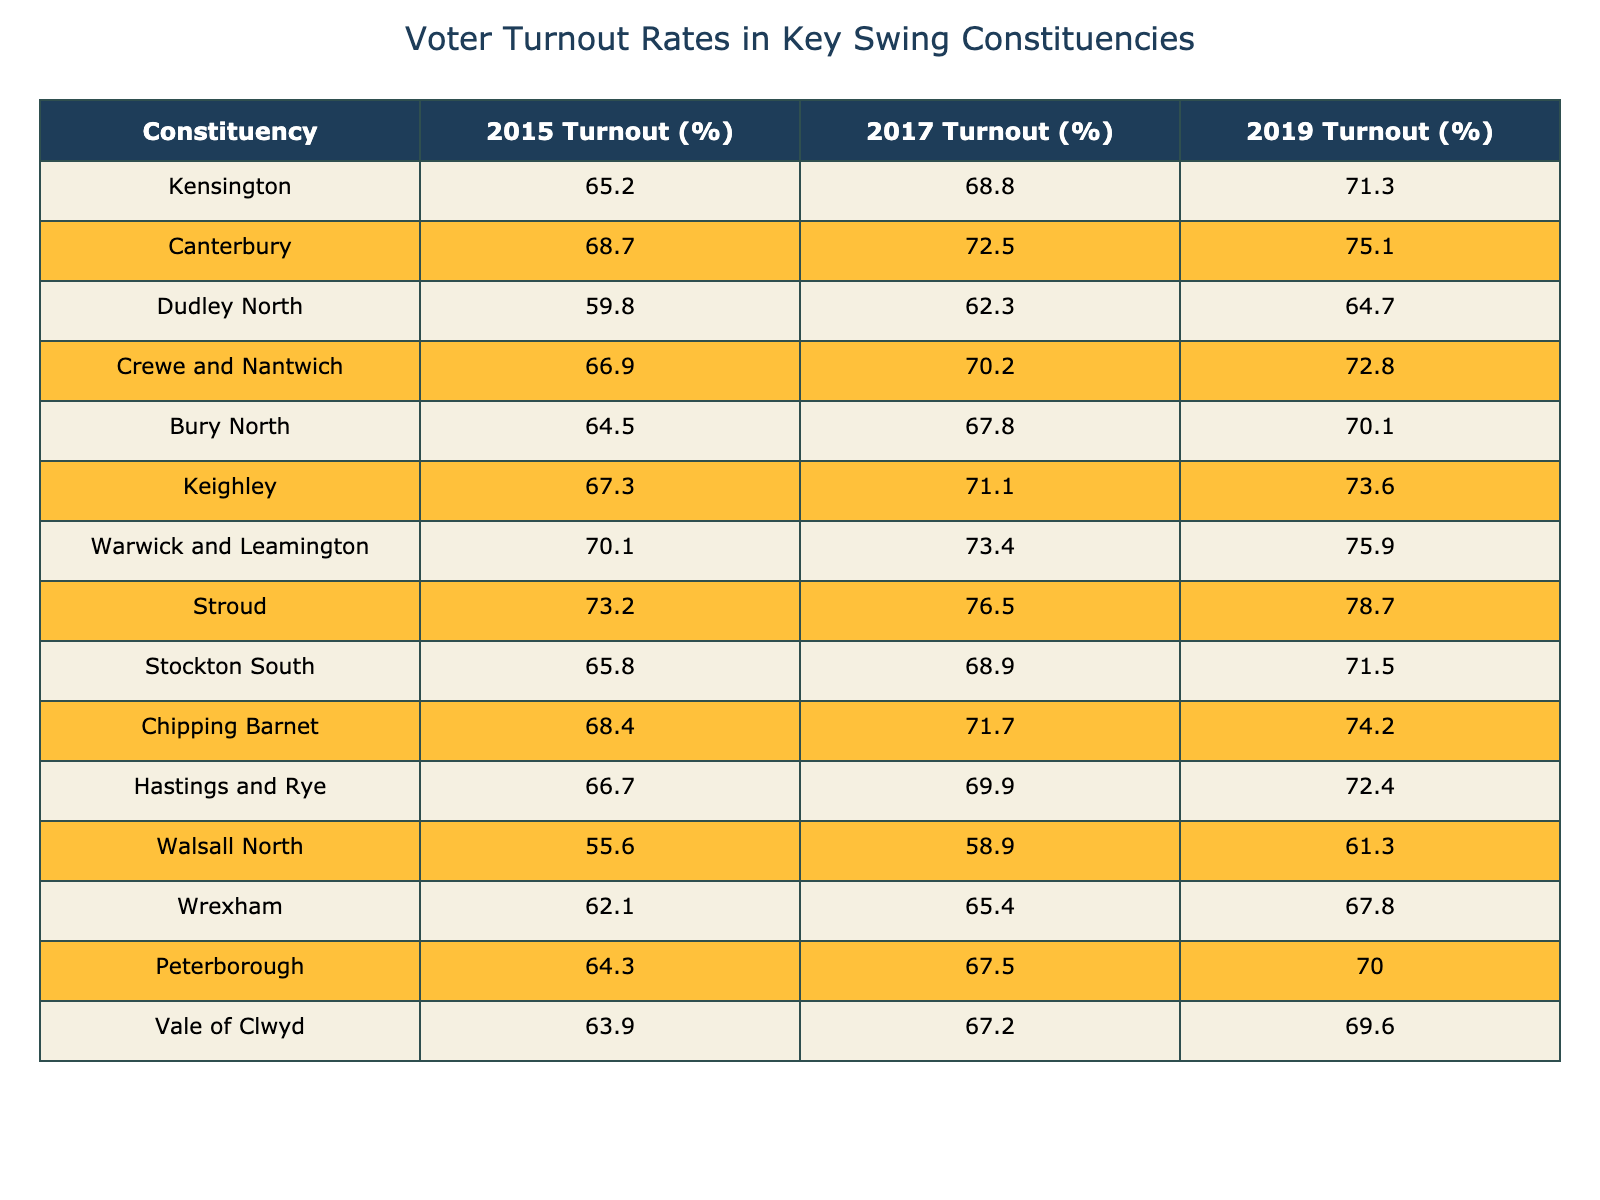What was the voter turnout rate in Kensington in 2017? The voter turnout rate in Kensington for 2017 is listed in the table as 68.8%. Therefore, the answer is straightforward as it can be directly retrieved from the table.
Answer: 68.8% Which constituency had the highest turnout in 2019? In 2019, the turnout percentages of constituencies are compared. By looking through the list, Stroud has the highest turnout rate at 78.7%.
Answer: Stroud What is the average voter turnout rate in the 2015 elections for constituencies starting with the letter 'C'? To find this, we first identify the constituencies that start with 'C': Canterbury (68.7%) and Crewe and Nantwich (66.9%). We then calculate the average: (68.7 + 66.9) / 2 = 67.8%.
Answer: 67.8% Did Walsall North have a higher voter turnout in 2019 than in 2015? In the table, Walsall North's turnout was 55.6% in 2015 and rose to 61.3% in 2019. Therefore, to answer the question, we compare the two values: 61.3% is higher than 55.6%.
Answer: Yes What was the difference in voter turnout for Peterborough between 2017 and 2019? We check the turnout rates for Peterborough: it was 67.5% in 2017 and 70.0% in 2019. To find the difference, we calculate 70.0% - 67.5% = 2.5%.
Answer: 2.5% In how many constituencies did the voter turnout increase from 2015 to 2019? We analyze the table to count the constituencies with increased turnout: Kensington, Canterbury, Dudley North, Crewe and Nantwich, Bury North, Keighley, Warwick and Leamington, Stroud, Stockton South, Chipping Barnet, Hastings and Rye, Wrexham, and Vale of Clwyd all showed an increase. Walsall North is the only constituency that did not. This makes a total of 13 constituencies.
Answer: 13 What was the percentage increase in turnout for Hastings and Rye from 2015 to 2019? We observe Hastings and Rye's turnout rates: it was 66.7% in 2015 and 72.4% in 2019. The percentage increase is calculated as: ((72.4 - 66.7) / 66.7) * 100 = 10.54%, which we can round to 10.5%.
Answer: 10.5% Is the turnout percentage in the 2019 elections for Wrexham lower than 70%? For Wrexham, the turnout rate in 2019 is 67.8%, which is compared to 70%. Since 67.8% is less than 70%, the answer is yes.
Answer: Yes 